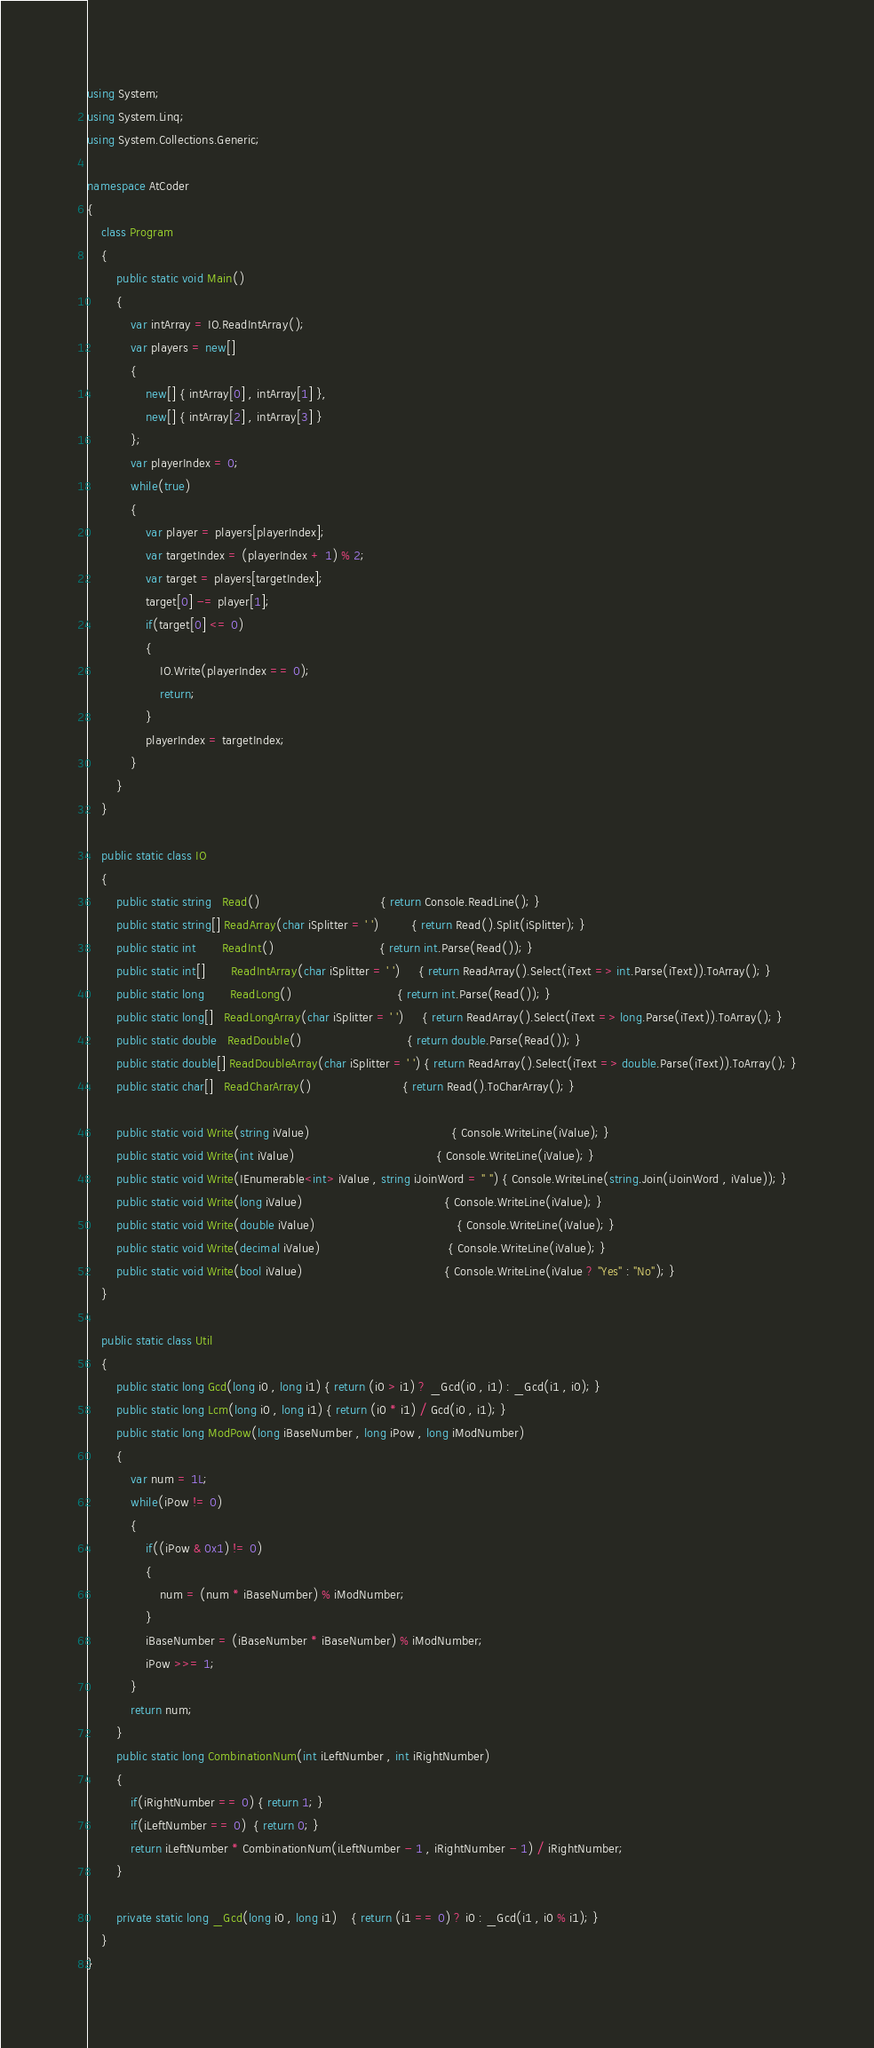<code> <loc_0><loc_0><loc_500><loc_500><_C#_>using System;
using System.Linq;
using System.Collections.Generic;

namespace AtCoder
{
	class Program
	{
		public static void Main()
		{
			var intArray = IO.ReadIntArray();
			var players = new[]
			{
				new[] { intArray[0] , intArray[1] },
				new[] { intArray[2] , intArray[3] }
			};
			var playerIndex = 0;
			while(true)
			{
				var player = players[playerIndex];
				var targetIndex = (playerIndex + 1) % 2;
				var target = players[targetIndex];
				target[0] -= player[1];
				if(target[0] <= 0)
				{
					IO.Write(playerIndex == 0);
					return;
				}
				playerIndex = targetIndex;
			}
		}
	}

	public static class IO
	{
		public static string   Read()								 { return Console.ReadLine(); }
		public static string[] ReadArray(char iSplitter = ' ')		 { return Read().Split(iSplitter); }
		public static int	   ReadInt()							 { return int.Parse(Read()); }
		public static int[]	   ReadIntArray(char iSplitter = ' ')	 { return ReadArray().Select(iText => int.Parse(iText)).ToArray(); }
		public static long	   ReadLong()							 { return int.Parse(Read()); }
		public static long[]   ReadLongArray(char iSplitter = ' ')	 { return ReadArray().Select(iText => long.Parse(iText)).ToArray(); }
		public static double   ReadDouble()							 { return double.Parse(Read()); }
		public static double[] ReadDoubleArray(char iSplitter = ' ') { return ReadArray().Select(iText => double.Parse(iText)).ToArray(); }
		public static char[]   ReadCharArray()						 { return Read().ToCharArray(); }

		public static void Write(string iValue)									   { Console.WriteLine(iValue); }
		public static void Write(int iValue)									   { Console.WriteLine(iValue); }
		public static void Write(IEnumerable<int> iValue , string iJoinWord = " ") { Console.WriteLine(string.Join(iJoinWord , iValue)); }
		public static void Write(long iValue)									   { Console.WriteLine(iValue); }
		public static void Write(double iValue)									   { Console.WriteLine(iValue); }
		public static void Write(decimal iValue)								   { Console.WriteLine(iValue); }
		public static void Write(bool iValue)									   { Console.WriteLine(iValue ? "Yes" : "No"); }
	}

	public static class Util
	{
		public static long Gcd(long i0 , long i1) { return (i0 > i1) ? _Gcd(i0 , i1) : _Gcd(i1 , i0); }
		public static long Lcm(long i0 , long i1) { return (i0 * i1) / Gcd(i0 , i1); }
		public static long ModPow(long iBaseNumber , long iPow , long iModNumber)
		{
			var num = 1L;
			while(iPow != 0)
			{
				if((iPow & 0x1) != 0)
				{
					num = (num * iBaseNumber) % iModNumber;
				}
				iBaseNumber = (iBaseNumber * iBaseNumber) % iModNumber;
				iPow >>= 1;
			}
			return num;
		}
		public static long CombinationNum(int iLeftNumber , int iRightNumber)
		{
			if(iRightNumber == 0) { return 1; }
			if(iLeftNumber == 0)  { return 0; }
			return iLeftNumber * CombinationNum(iLeftNumber - 1 , iRightNumber - 1) / iRightNumber;
		}

		private static long _Gcd(long i0 , long i1)	{ return (i1 == 0) ? i0 : _Gcd(i1 , i0 % i1); }
	}
}
</code> 